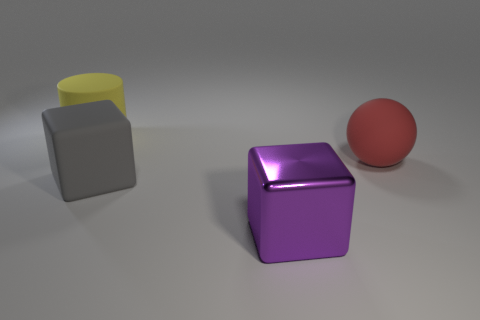How would you describe the function of these objects, assuming they are part of a children's play set? Given their rubber material and basic geometric shapes, these objects could serve as educational tools for children, helping them learn about colors, shapes, and spatial relationships. For instance, the purple cube could teach kids about squares and cubes, the grey object might be a cylinder to demonstrate circles and cylinders, while the red ball can be used to explain spheres and the concept of rolling. 